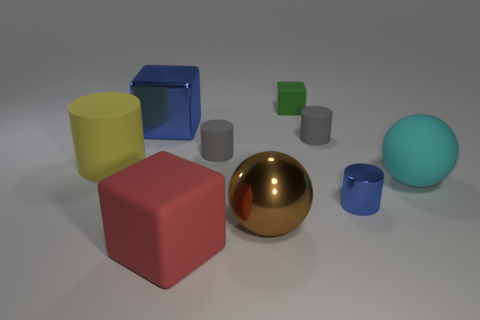Is there any other thing that is the same shape as the big brown thing?
Offer a very short reply. Yes. How many objects are either big metallic cylinders or big metal things?
Your answer should be very brief. 2. Does the brown shiny object have the same shape as the small rubber object on the left side of the green matte cube?
Offer a terse response. No. There is a blue object in front of the cyan ball; what is its shape?
Offer a very short reply. Cylinder. Is the shape of the red thing the same as the yellow rubber thing?
Provide a succinct answer. No. The metal thing that is the same shape as the large yellow matte thing is what size?
Offer a terse response. Small. Does the cylinder that is in front of the cyan rubber thing have the same size as the tiny green block?
Your response must be concise. Yes. There is a metal object that is both left of the small blue cylinder and right of the red rubber cube; what is its size?
Your answer should be very brief. Large. There is a block that is the same color as the small metallic cylinder; what is its material?
Provide a succinct answer. Metal. What number of tiny rubber cylinders have the same color as the metallic ball?
Ensure brevity in your answer.  0. 